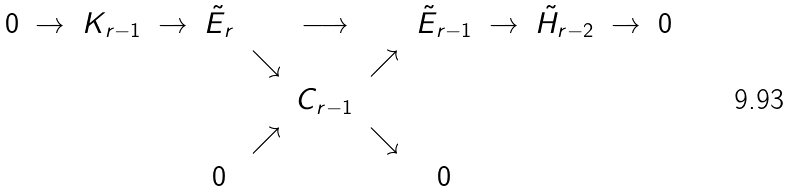<formula> <loc_0><loc_0><loc_500><loc_500>\begin{array} { c c c c c c c c c c c c c } 0 & \to & K _ { r - 1 } & \to & { \tilde { E } } _ { r } & & \longrightarrow & & { \tilde { E } } _ { r - 1 } & \to & { \tilde { H } } _ { r - 2 } & \to & 0 \\ & & & & & \searrow & & \nearrow & & & & & \\ & & & & & & C _ { r - 1 } & & & & & & \\ & & & & & \nearrow & & \searrow & & & & & \\ & & & & 0 & & & & 0 & & & & \end{array}</formula> 